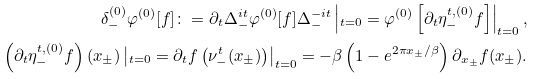Convert formula to latex. <formula><loc_0><loc_0><loc_500><loc_500>\delta _ { - } ^ { ( 0 ) } \varphi ^ { ( 0 ) } [ f ] \colon = \partial _ { t } \Delta _ { - } ^ { i t } \varphi ^ { ( 0 ) } [ f ] \Delta _ { - } ^ { - i t } \left | _ { t = 0 } = \varphi ^ { ( 0 ) } \left [ \partial _ { t } \eta _ { - } ^ { t , ( 0 ) } f \right ] \right | _ { t = 0 } , \\ \left ( \partial _ { t } \eta _ { - } ^ { t , ( 0 ) } f \right ) ( x _ { \pm } ) \left | _ { t = 0 } = \partial _ { t } f \left ( \nu _ { - } ^ { t } ( x _ { \pm } ) \right ) \right | _ { t = 0 } = - \beta \left ( 1 - e ^ { 2 \pi x _ { \pm } / \beta } \right ) \partial _ { x _ { \pm } } f ( x _ { \pm } ) .</formula> 